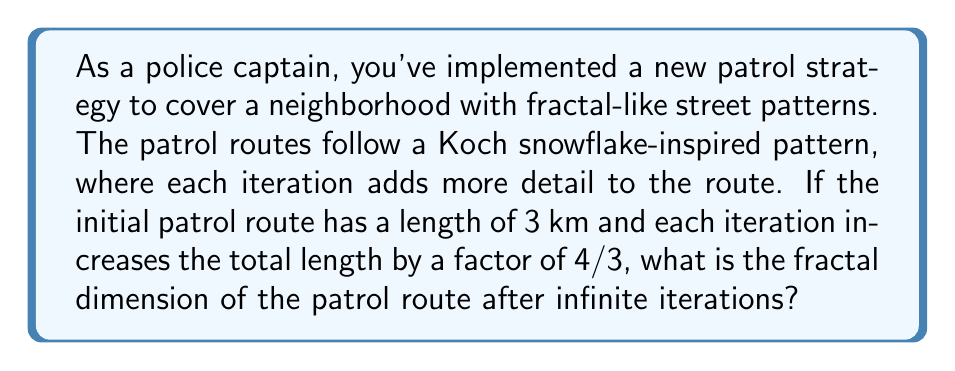Help me with this question. To calculate the fractal dimension of the patrol route, we'll use the box-counting dimension formula:

$$D = \frac{\log N}{\log (1/r)}$$

Where:
$D$ = fractal dimension
$N$ = number of self-similar pieces
$r$ = scaling factor

For the Koch snowflake-inspired patrol route:

1. In each iteration, each line segment is replaced by 4 smaller segments.
   So, $N = 4$

2. The scaling factor is the inverse of the length increase:
   $r = \frac{3}{4}$

3. Substituting these values into the formula:

   $$D = \frac{\log 4}{\log (1/(3/4))} = \frac{\log 4}{\log (4/3)}$$

4. Simplify:
   $$D = \frac{\log 4}{\log 4 - \log 3}$$

5. Calculate the value:
   $$D \approx 1.2618595071429148$$

This fractal dimension indicates that the patrol route is more complex than a simple line (dimension 1) but less space-filling than a plane (dimension 2), allowing for efficient coverage of the neighborhood.
Answer: $\frac{\log 4}{\log 4 - \log 3} \approx 1.2619$ 